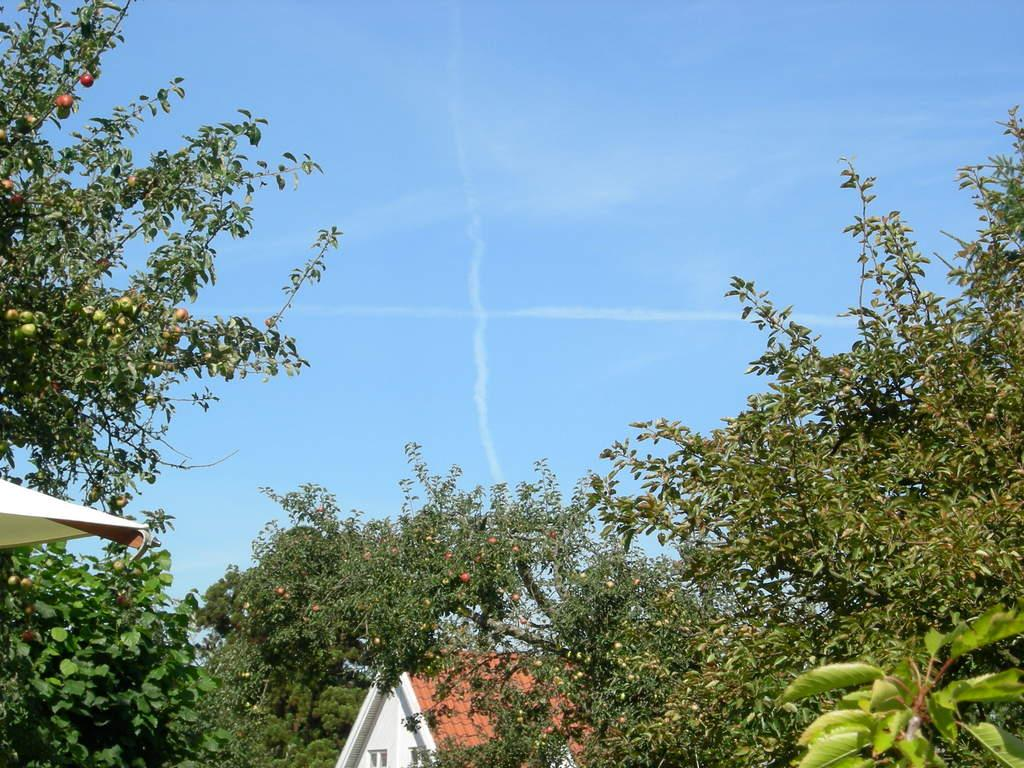What type of vegetation can be seen in the image? There are trees in the image. What structure is located at the bottom of the image? There is a house at the bottom of the image. What is visible at the top of the image? The sky is visible at the top of the image. What can be seen on the left side of the image? There is an object on the left side of the image. What time of day is indicated by the hour on the tree in the image? There is no hour or clock present on the tree in the image. How does the zipper on the tree function in the image? There is no zipper present on the tree in the image. 